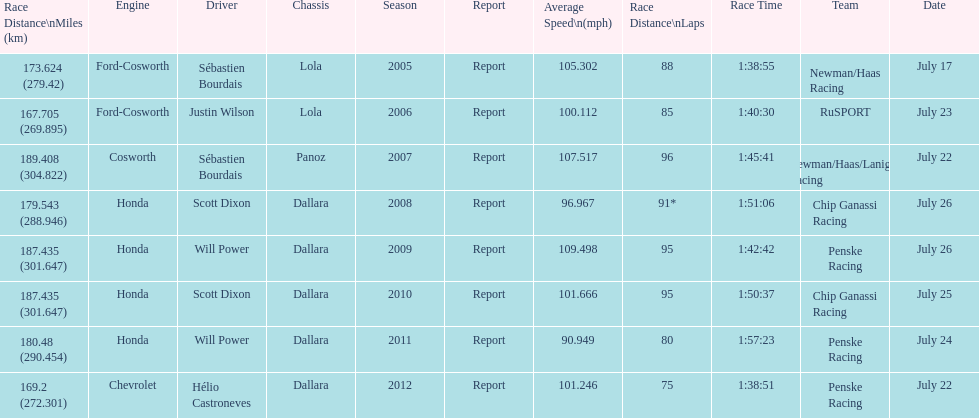What is the least amount of laps completed? 75. 